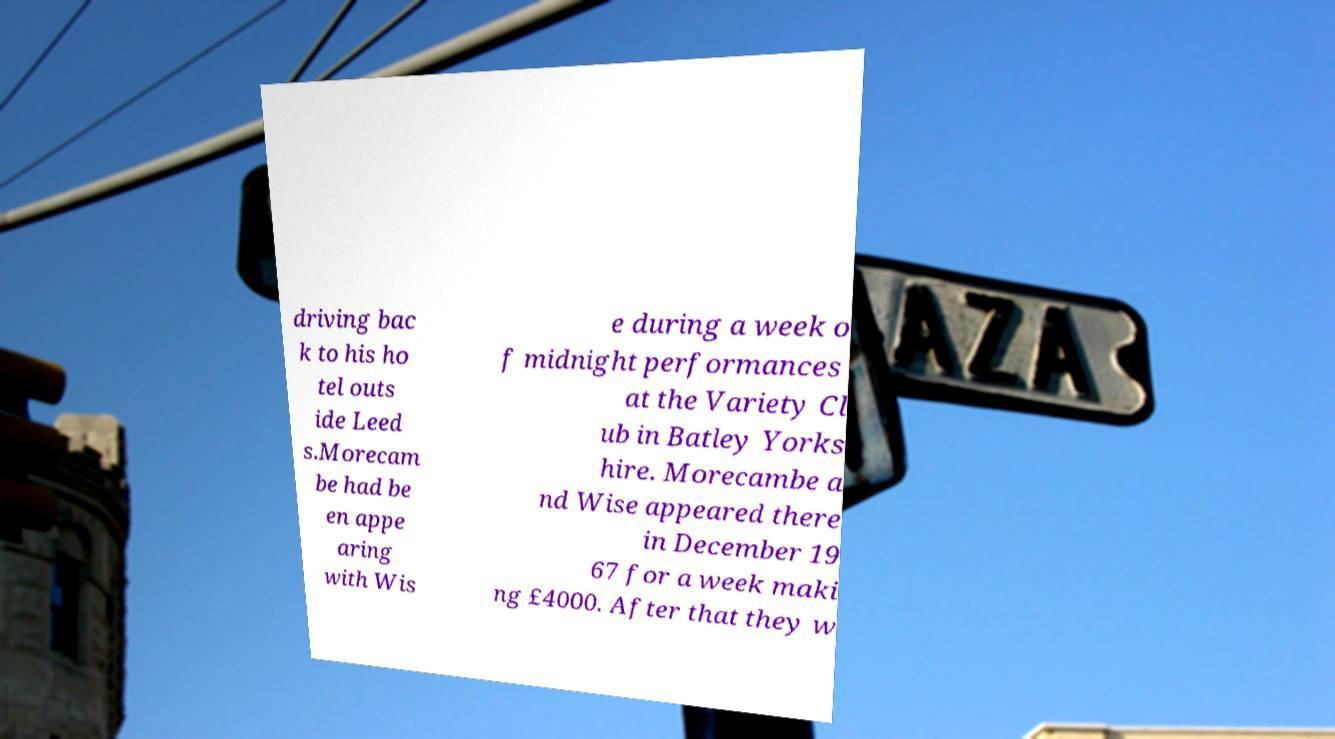Can you read and provide the text displayed in the image?This photo seems to have some interesting text. Can you extract and type it out for me? driving bac k to his ho tel outs ide Leed s.Morecam be had be en appe aring with Wis e during a week o f midnight performances at the Variety Cl ub in Batley Yorks hire. Morecambe a nd Wise appeared there in December 19 67 for a week maki ng £4000. After that they w 